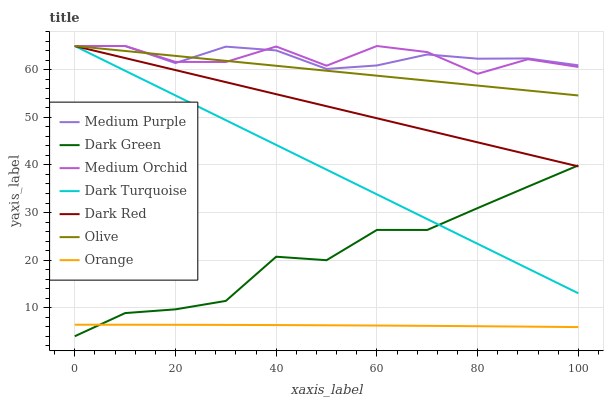Does Orange have the minimum area under the curve?
Answer yes or no. Yes. Does Medium Purple have the maximum area under the curve?
Answer yes or no. Yes. Does Medium Orchid have the minimum area under the curve?
Answer yes or no. No. Does Medium Orchid have the maximum area under the curve?
Answer yes or no. No. Is Dark Turquoise the smoothest?
Answer yes or no. Yes. Is Medium Orchid the roughest?
Answer yes or no. Yes. Is Medium Purple the smoothest?
Answer yes or no. No. Is Medium Purple the roughest?
Answer yes or no. No. Does Medium Orchid have the lowest value?
Answer yes or no. No. Does Orange have the highest value?
Answer yes or no. No. Is Dark Green less than Medium Purple?
Answer yes or no. Yes. Is Olive greater than Dark Green?
Answer yes or no. Yes. Does Dark Green intersect Medium Purple?
Answer yes or no. No. 